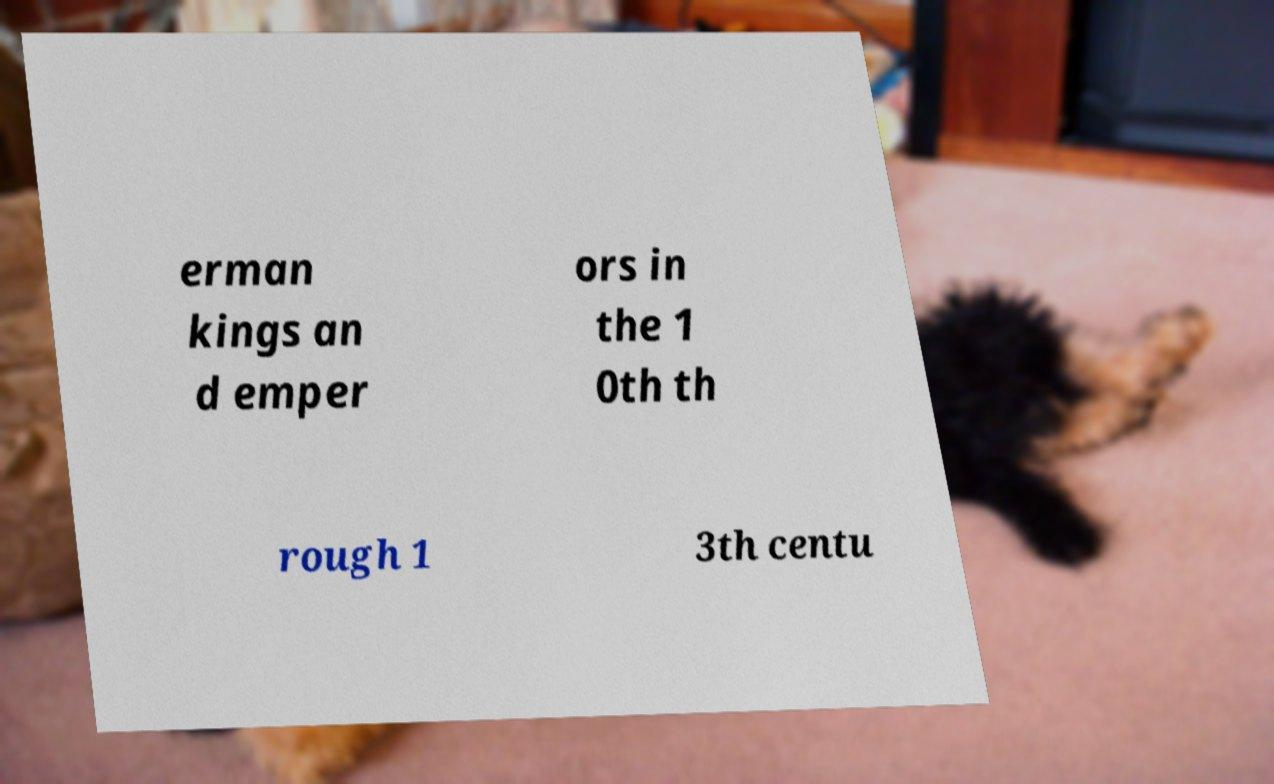There's text embedded in this image that I need extracted. Can you transcribe it verbatim? erman kings an d emper ors in the 1 0th th rough 1 3th centu 